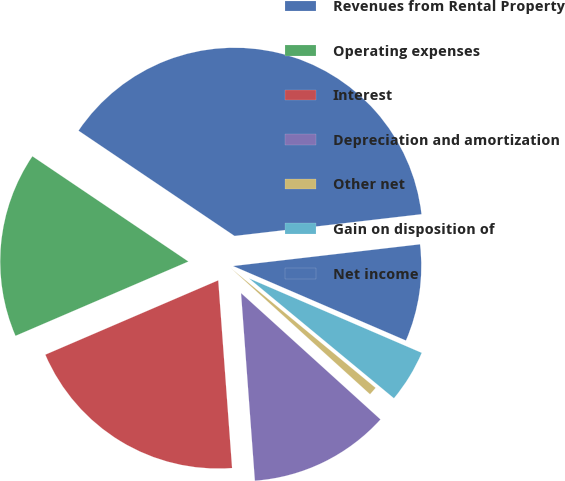<chart> <loc_0><loc_0><loc_500><loc_500><pie_chart><fcel>Revenues from Rental Property<fcel>Operating expenses<fcel>Interest<fcel>Depreciation and amortization<fcel>Other net<fcel>Gain on disposition of<fcel>Net income<nl><fcel>38.71%<fcel>15.91%<fcel>19.71%<fcel>12.11%<fcel>0.72%<fcel>4.52%<fcel>8.32%<nl></chart> 